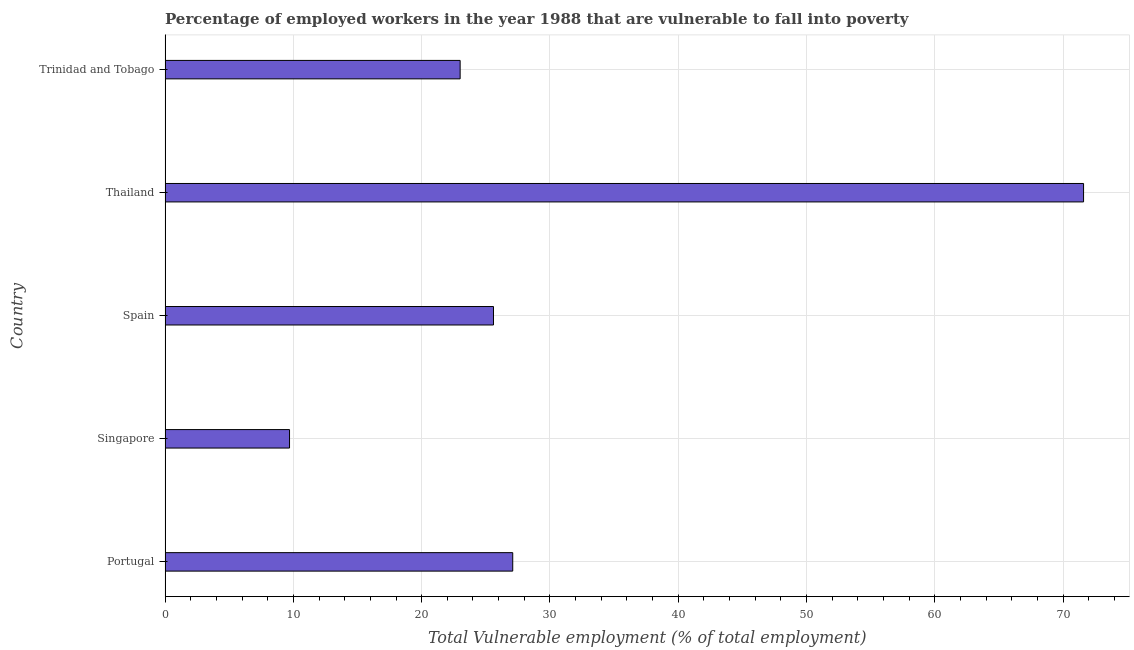Does the graph contain any zero values?
Offer a terse response. No. Does the graph contain grids?
Your answer should be compact. Yes. What is the title of the graph?
Provide a short and direct response. Percentage of employed workers in the year 1988 that are vulnerable to fall into poverty. What is the label or title of the X-axis?
Make the answer very short. Total Vulnerable employment (% of total employment). What is the label or title of the Y-axis?
Keep it short and to the point. Country. What is the total vulnerable employment in Portugal?
Your answer should be very brief. 27.1. Across all countries, what is the maximum total vulnerable employment?
Provide a short and direct response. 71.6. Across all countries, what is the minimum total vulnerable employment?
Give a very brief answer. 9.7. In which country was the total vulnerable employment maximum?
Your response must be concise. Thailand. In which country was the total vulnerable employment minimum?
Your response must be concise. Singapore. What is the sum of the total vulnerable employment?
Your answer should be very brief. 157. What is the difference between the total vulnerable employment in Singapore and Spain?
Keep it short and to the point. -15.9. What is the average total vulnerable employment per country?
Provide a succinct answer. 31.4. What is the median total vulnerable employment?
Offer a terse response. 25.6. What is the ratio of the total vulnerable employment in Singapore to that in Trinidad and Tobago?
Provide a short and direct response. 0.42. What is the difference between the highest and the second highest total vulnerable employment?
Make the answer very short. 44.5. Is the sum of the total vulnerable employment in Portugal and Trinidad and Tobago greater than the maximum total vulnerable employment across all countries?
Provide a succinct answer. No. What is the difference between the highest and the lowest total vulnerable employment?
Offer a very short reply. 61.9. In how many countries, is the total vulnerable employment greater than the average total vulnerable employment taken over all countries?
Provide a succinct answer. 1. How many bars are there?
Your answer should be compact. 5. What is the difference between two consecutive major ticks on the X-axis?
Provide a succinct answer. 10. Are the values on the major ticks of X-axis written in scientific E-notation?
Provide a succinct answer. No. What is the Total Vulnerable employment (% of total employment) in Portugal?
Provide a succinct answer. 27.1. What is the Total Vulnerable employment (% of total employment) in Singapore?
Give a very brief answer. 9.7. What is the Total Vulnerable employment (% of total employment) of Spain?
Your answer should be very brief. 25.6. What is the Total Vulnerable employment (% of total employment) of Thailand?
Give a very brief answer. 71.6. What is the difference between the Total Vulnerable employment (% of total employment) in Portugal and Singapore?
Provide a succinct answer. 17.4. What is the difference between the Total Vulnerable employment (% of total employment) in Portugal and Thailand?
Offer a very short reply. -44.5. What is the difference between the Total Vulnerable employment (% of total employment) in Portugal and Trinidad and Tobago?
Provide a succinct answer. 4.1. What is the difference between the Total Vulnerable employment (% of total employment) in Singapore and Spain?
Your answer should be compact. -15.9. What is the difference between the Total Vulnerable employment (% of total employment) in Singapore and Thailand?
Give a very brief answer. -61.9. What is the difference between the Total Vulnerable employment (% of total employment) in Spain and Thailand?
Give a very brief answer. -46. What is the difference between the Total Vulnerable employment (% of total employment) in Spain and Trinidad and Tobago?
Ensure brevity in your answer.  2.6. What is the difference between the Total Vulnerable employment (% of total employment) in Thailand and Trinidad and Tobago?
Provide a short and direct response. 48.6. What is the ratio of the Total Vulnerable employment (% of total employment) in Portugal to that in Singapore?
Offer a terse response. 2.79. What is the ratio of the Total Vulnerable employment (% of total employment) in Portugal to that in Spain?
Provide a succinct answer. 1.06. What is the ratio of the Total Vulnerable employment (% of total employment) in Portugal to that in Thailand?
Your answer should be compact. 0.38. What is the ratio of the Total Vulnerable employment (% of total employment) in Portugal to that in Trinidad and Tobago?
Ensure brevity in your answer.  1.18. What is the ratio of the Total Vulnerable employment (% of total employment) in Singapore to that in Spain?
Keep it short and to the point. 0.38. What is the ratio of the Total Vulnerable employment (% of total employment) in Singapore to that in Thailand?
Your response must be concise. 0.14. What is the ratio of the Total Vulnerable employment (% of total employment) in Singapore to that in Trinidad and Tobago?
Offer a very short reply. 0.42. What is the ratio of the Total Vulnerable employment (% of total employment) in Spain to that in Thailand?
Give a very brief answer. 0.36. What is the ratio of the Total Vulnerable employment (% of total employment) in Spain to that in Trinidad and Tobago?
Offer a very short reply. 1.11. What is the ratio of the Total Vulnerable employment (% of total employment) in Thailand to that in Trinidad and Tobago?
Keep it short and to the point. 3.11. 